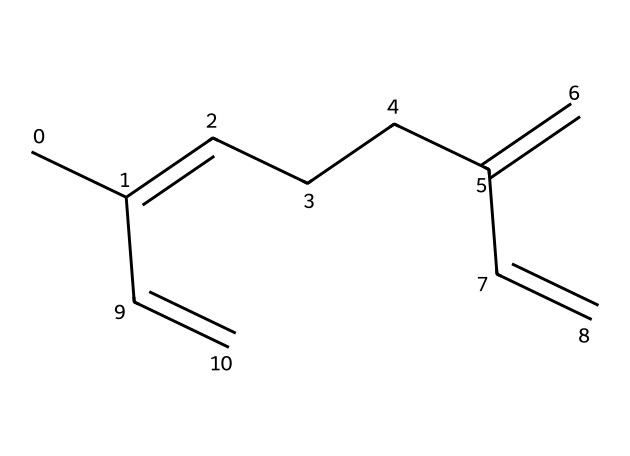What is the molecular formula of myrcene? To find the molecular formula, count the number of carbon (C) and hydrogen (H) atoms in the SMILES representation. Starting from the left, there are 10 carbon atoms and 16 hydrogen atoms. Therefore, the molecular formula is C10H16.
Answer: C10H16 How many double bonds are present in myrcene? Analyzing the SMILES structure, there are four distinct double bonds shown in the formula. Each '=' indicates a double bond, and counting them gives the total.
Answer: 4 Is myrcene a cyclic or acyclic compound? By examining the structure derived from the SMILES notation, there are no rings present; all carbon atoms are arranged in a linear form, which signifies that myrcene is an acyclic compound.
Answer: acyclic What is the primary function of myrcene in aromatic plants? Myrcene is known for its role as a terpene in aromatic plants, primarily offering stress-relief properties; it acts as a natural anti-inflammatory and calming agent.
Answer: stress-relief Which class of terpenes does myrcene belong to? Myrcene is classified as a "monoterpene," which consists of two isoprene units. The structure reveals its size and the presence of only ten carbon atoms, confirming its classification.
Answer: monoterpene What characteristic odor is associated with myrcene? Myrcene typically possesses a musky, earthy scent akin to cloves, which is prominent among aromatic plants. This sensory quality helps in identifying its presence in various products.
Answer: musky What is the significance of myrcene's structure in its effects? The structure of myrcene, with multiple double bonds, enhances its reactivity and ability to interact with biological systems, which contributes to its calming effects when used in stress-relief products.
Answer: reactivity 